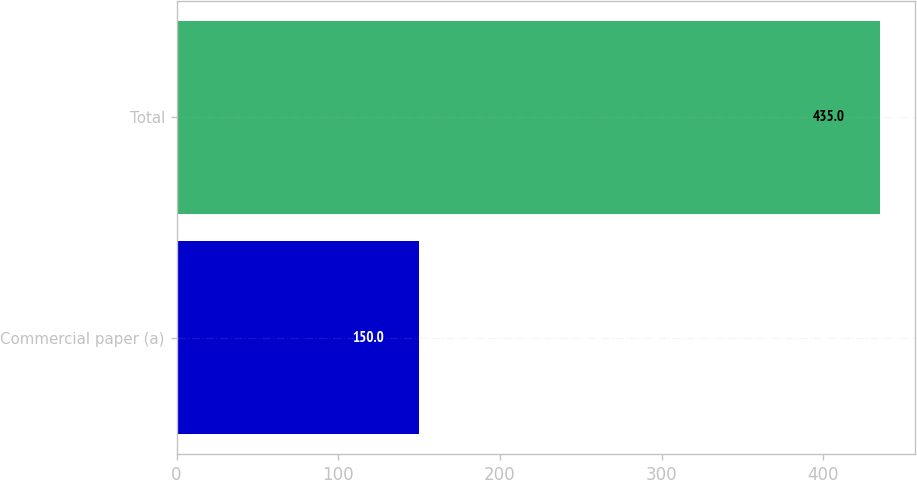<chart> <loc_0><loc_0><loc_500><loc_500><bar_chart><fcel>Commercial paper (a)<fcel>Total<nl><fcel>150<fcel>435<nl></chart> 